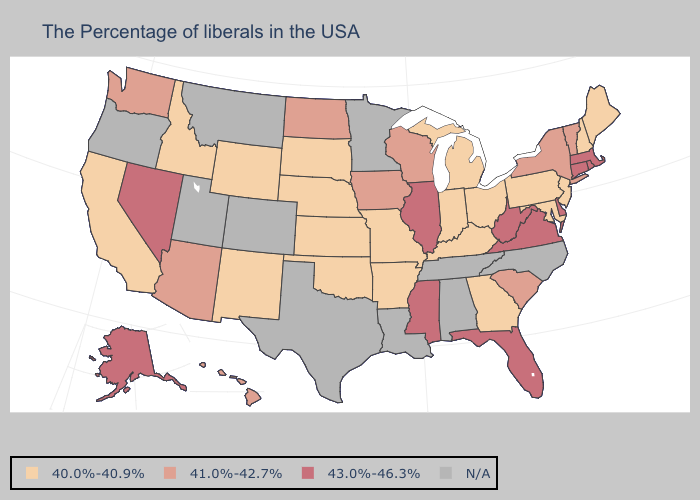Which states have the lowest value in the USA?
Keep it brief. Maine, New Hampshire, New Jersey, Maryland, Pennsylvania, Ohio, Georgia, Michigan, Kentucky, Indiana, Missouri, Arkansas, Kansas, Nebraska, Oklahoma, South Dakota, Wyoming, New Mexico, Idaho, California. Among the states that border Arkansas , which have the lowest value?
Write a very short answer. Missouri, Oklahoma. Does the map have missing data?
Concise answer only. Yes. What is the value of Minnesota?
Give a very brief answer. N/A. Name the states that have a value in the range 40.0%-40.9%?
Write a very short answer. Maine, New Hampshire, New Jersey, Maryland, Pennsylvania, Ohio, Georgia, Michigan, Kentucky, Indiana, Missouri, Arkansas, Kansas, Nebraska, Oklahoma, South Dakota, Wyoming, New Mexico, Idaho, California. Which states have the lowest value in the USA?
Short answer required. Maine, New Hampshire, New Jersey, Maryland, Pennsylvania, Ohio, Georgia, Michigan, Kentucky, Indiana, Missouri, Arkansas, Kansas, Nebraska, Oklahoma, South Dakota, Wyoming, New Mexico, Idaho, California. Name the states that have a value in the range 41.0%-42.7%?
Be succinct. Vermont, New York, South Carolina, Wisconsin, Iowa, North Dakota, Arizona, Washington, Hawaii. What is the value of West Virginia?
Be succinct. 43.0%-46.3%. How many symbols are there in the legend?
Concise answer only. 4. Among the states that border Colorado , does Arizona have the highest value?
Give a very brief answer. Yes. What is the value of Ohio?
Be succinct. 40.0%-40.9%. Among the states that border Iowa , does Missouri have the highest value?
Be succinct. No. Name the states that have a value in the range 43.0%-46.3%?
Give a very brief answer. Massachusetts, Rhode Island, Connecticut, Delaware, Virginia, West Virginia, Florida, Illinois, Mississippi, Nevada, Alaska. 